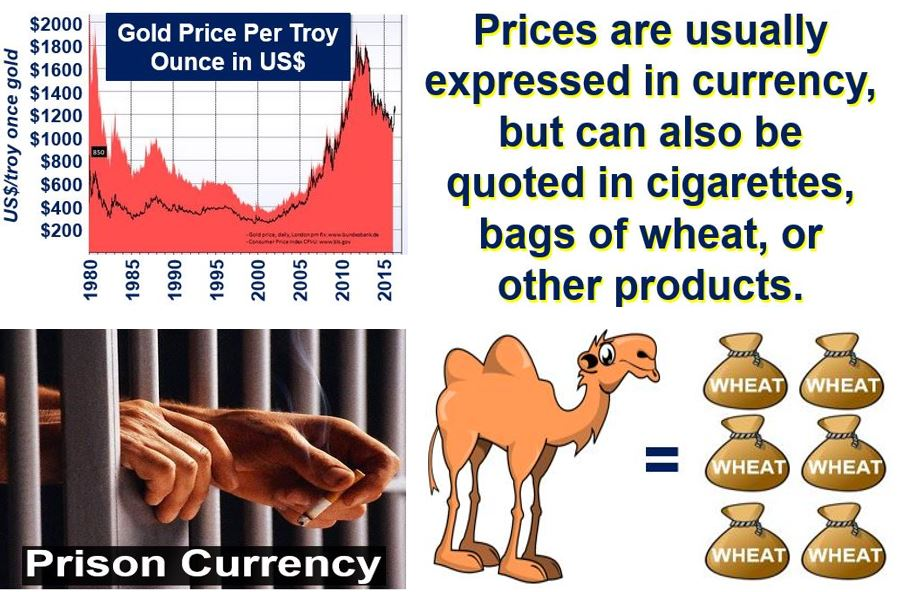The image shows the price fluctuation of gold over years. How does the value stability of unconventional currency in prisons compare to that of gold? Unconventional currency in prisons, such as cigarettes or wheat, tends to have more stability in their value compared to traditional commodities like gold seen in the image. Gold prices fluctuate significantly due to various economic factors, whereas in a prison environment, the value of items like cigarettes remains relatively stable as they are directly correlated with immediate demand and supply within a closed economy with limited inflow of these goods. Could you elaborate on why the value of items like cigarettes could remain stable in prison? In a prison environment, the value of items like cigarettes usually remains stable because of the consistent, high demand among the inmates and the controlled, limited supply. Cigarettes serve as a practical medium of exchange, similar to money, because they are divisible, durable, and widely desired. Inmates often use them for barter, which maintains their value stability. Since the prison economy is relatively isolated from external economic influences, the valuation of commonly used items like cigarettes doesn't experience the sharegpt4v/same volatility as global commodities such as gold. 